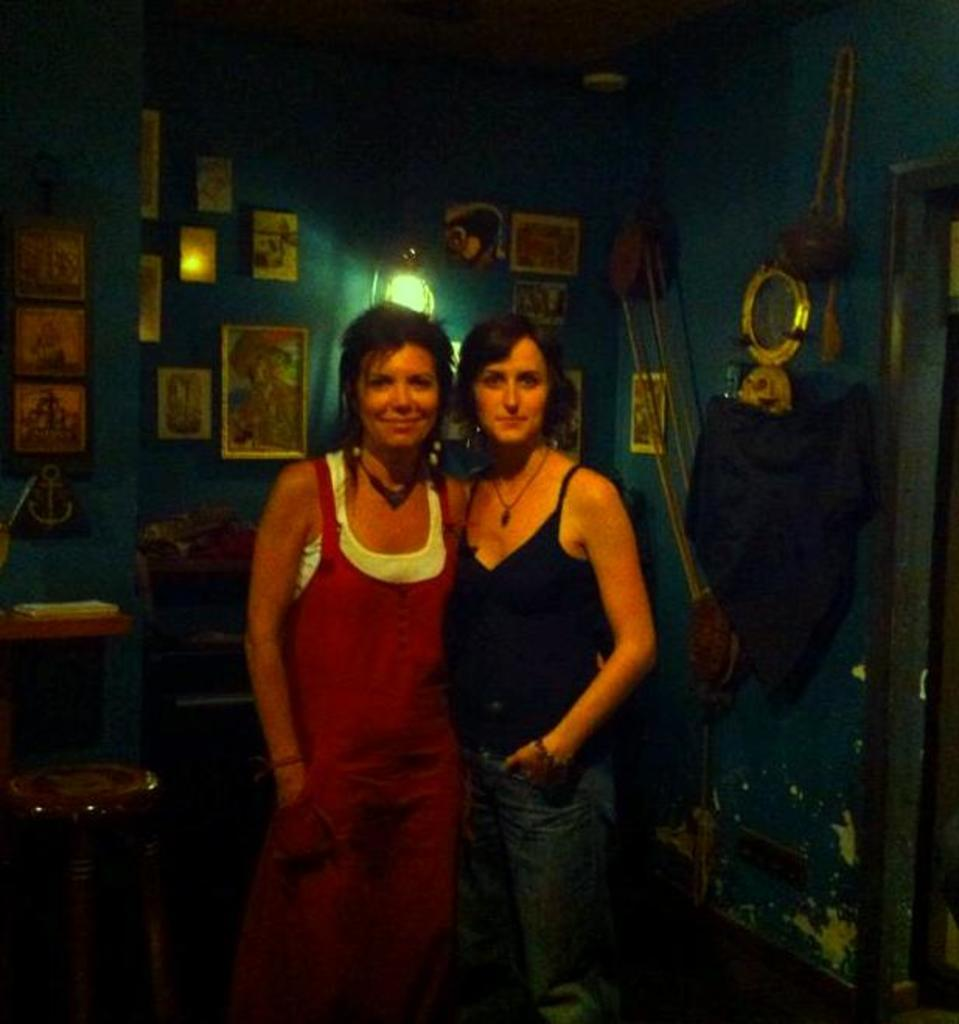How many people are in the image? There are two women in the image. What are the women doing in the image? The women are standing and laughing. What can be seen in the background of the image? There is a wall frame and a light in the background of the image. Are there any other objects on the wall in the background? Yes, there are other objects on the wall in the background. What type of competition is taking place between the women in the image? There is no competition present in the image; the women are simply standing and laughing. What kind of beast can be seen lurking in the background of the image? There is no beast present in the image; the background features a wall frame, a light, and other objects. 